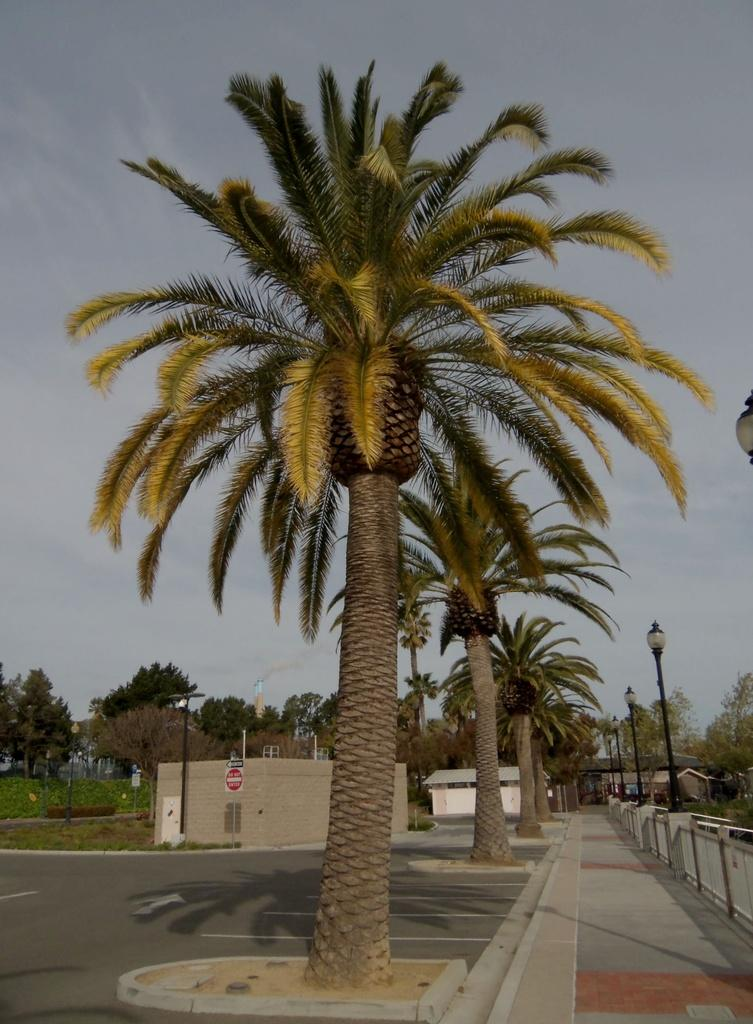What type of vegetation can be seen in the image? There are trees in the image. What is the purpose of the signboard in the image? The purpose of the signboard is not specified in the image, but it could be providing information or advertising. What structures are present in the image to provide illumination? There are light poles in the image to provide illumination. What type of building can be seen in the background of the image? There is a house in the background of the image. What type of barrier is present in the background of the image? There is fencing in the background of the image. What is the color of the sky in the image? The sky is blue and white in color. What is the organization's opinion on the sofa in the image? There is no organization or sofa present in the image, so it is not possible to determine their opinion. 